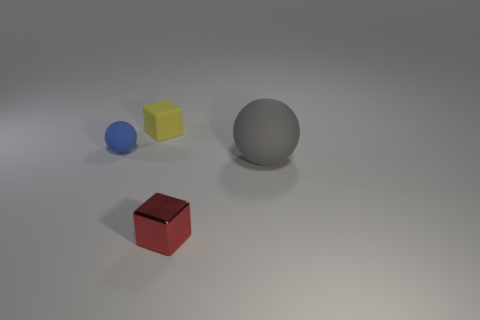What is the material of the ball that is behind the thing on the right side of the tiny red metallic object?
Ensure brevity in your answer.  Rubber. Is the size of the matte ball that is to the right of the red object the same as the small red metallic thing?
Your answer should be very brief. No. Are there any large things of the same color as the large matte ball?
Your answer should be compact. No. What number of things are blocks in front of the big gray sphere or small objects that are in front of the small ball?
Give a very brief answer. 1. Is the number of big gray things that are to the left of the tiny yellow rubber object less than the number of big things in front of the tiny rubber ball?
Make the answer very short. Yes. Does the large gray sphere have the same material as the yellow block?
Your answer should be compact. Yes. There is a object that is both in front of the blue rubber object and behind the red metal block; how big is it?
Ensure brevity in your answer.  Large. There is a blue rubber object that is the same size as the red thing; what shape is it?
Provide a succinct answer. Sphere. What is the material of the cube behind the sphere right of the ball behind the large gray matte sphere?
Your answer should be very brief. Rubber. There is a object right of the tiny red block; does it have the same shape as the tiny thing that is to the left of the small yellow cube?
Provide a short and direct response. Yes. 